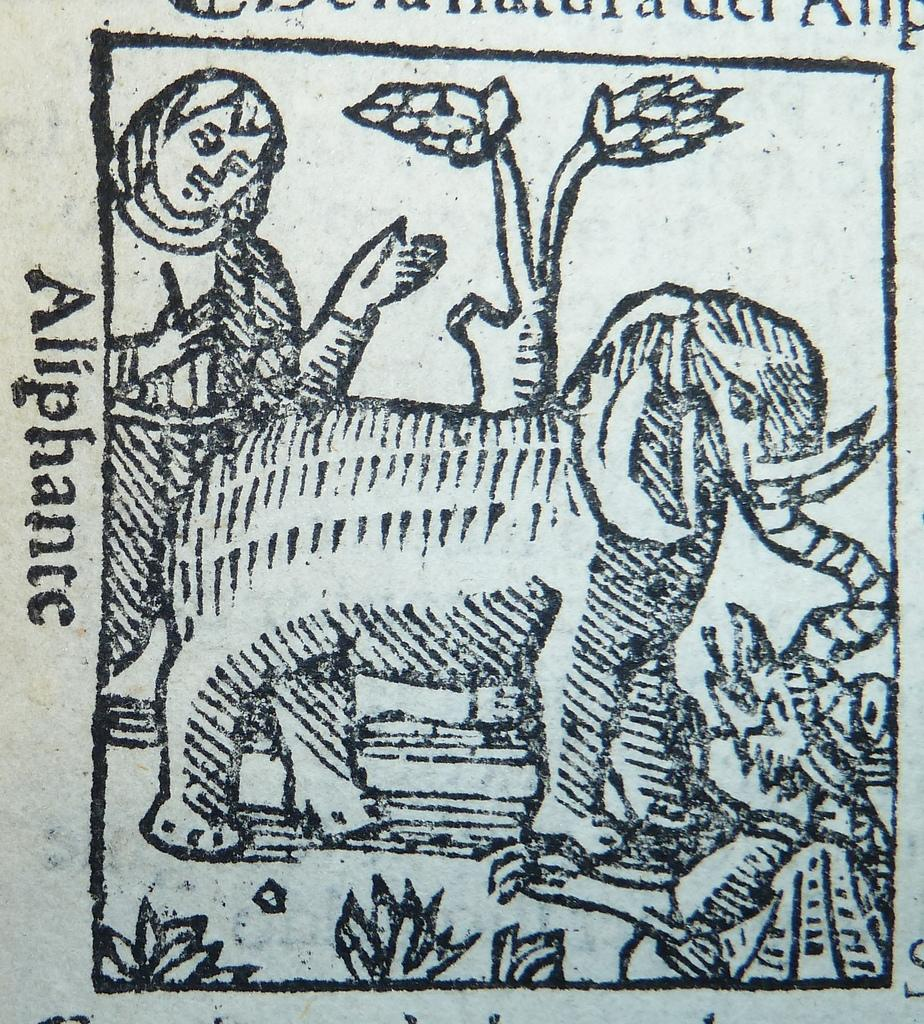What type of artwork is depicted in the image? The image is a drawing. What animal is featured in the drawing? There is an elephant in the drawing. How many people are present in the drawing? There is one person in the drawing. What type of vegetation is present in the drawing? There are plants and a tree in the drawing. Is there any text included in the drawing? Yes, there is text in the drawing. What type of rail system is visible in the drawing? There is no rail system present in the drawing; it features an elephant, a person, plants, a tree, and text. 